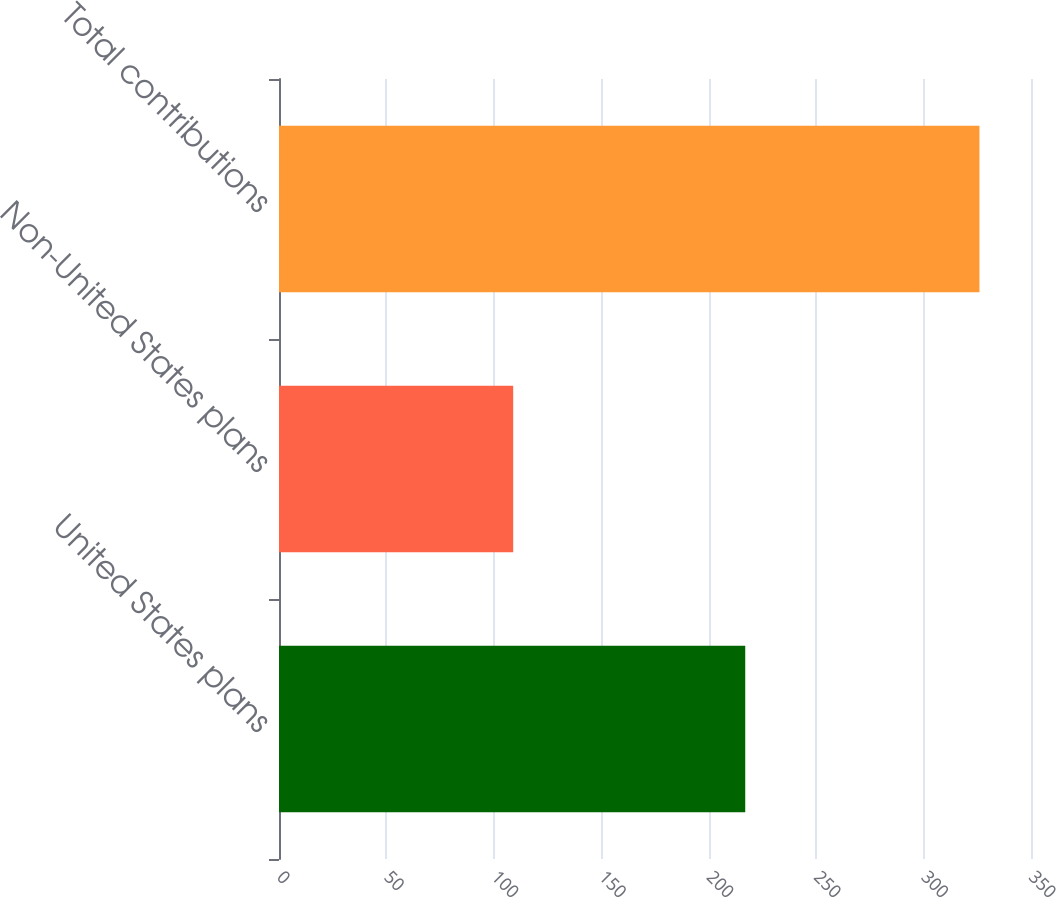Convert chart to OTSL. <chart><loc_0><loc_0><loc_500><loc_500><bar_chart><fcel>United States plans<fcel>Non-United States plans<fcel>Total contributions<nl><fcel>217<fcel>109<fcel>326<nl></chart> 